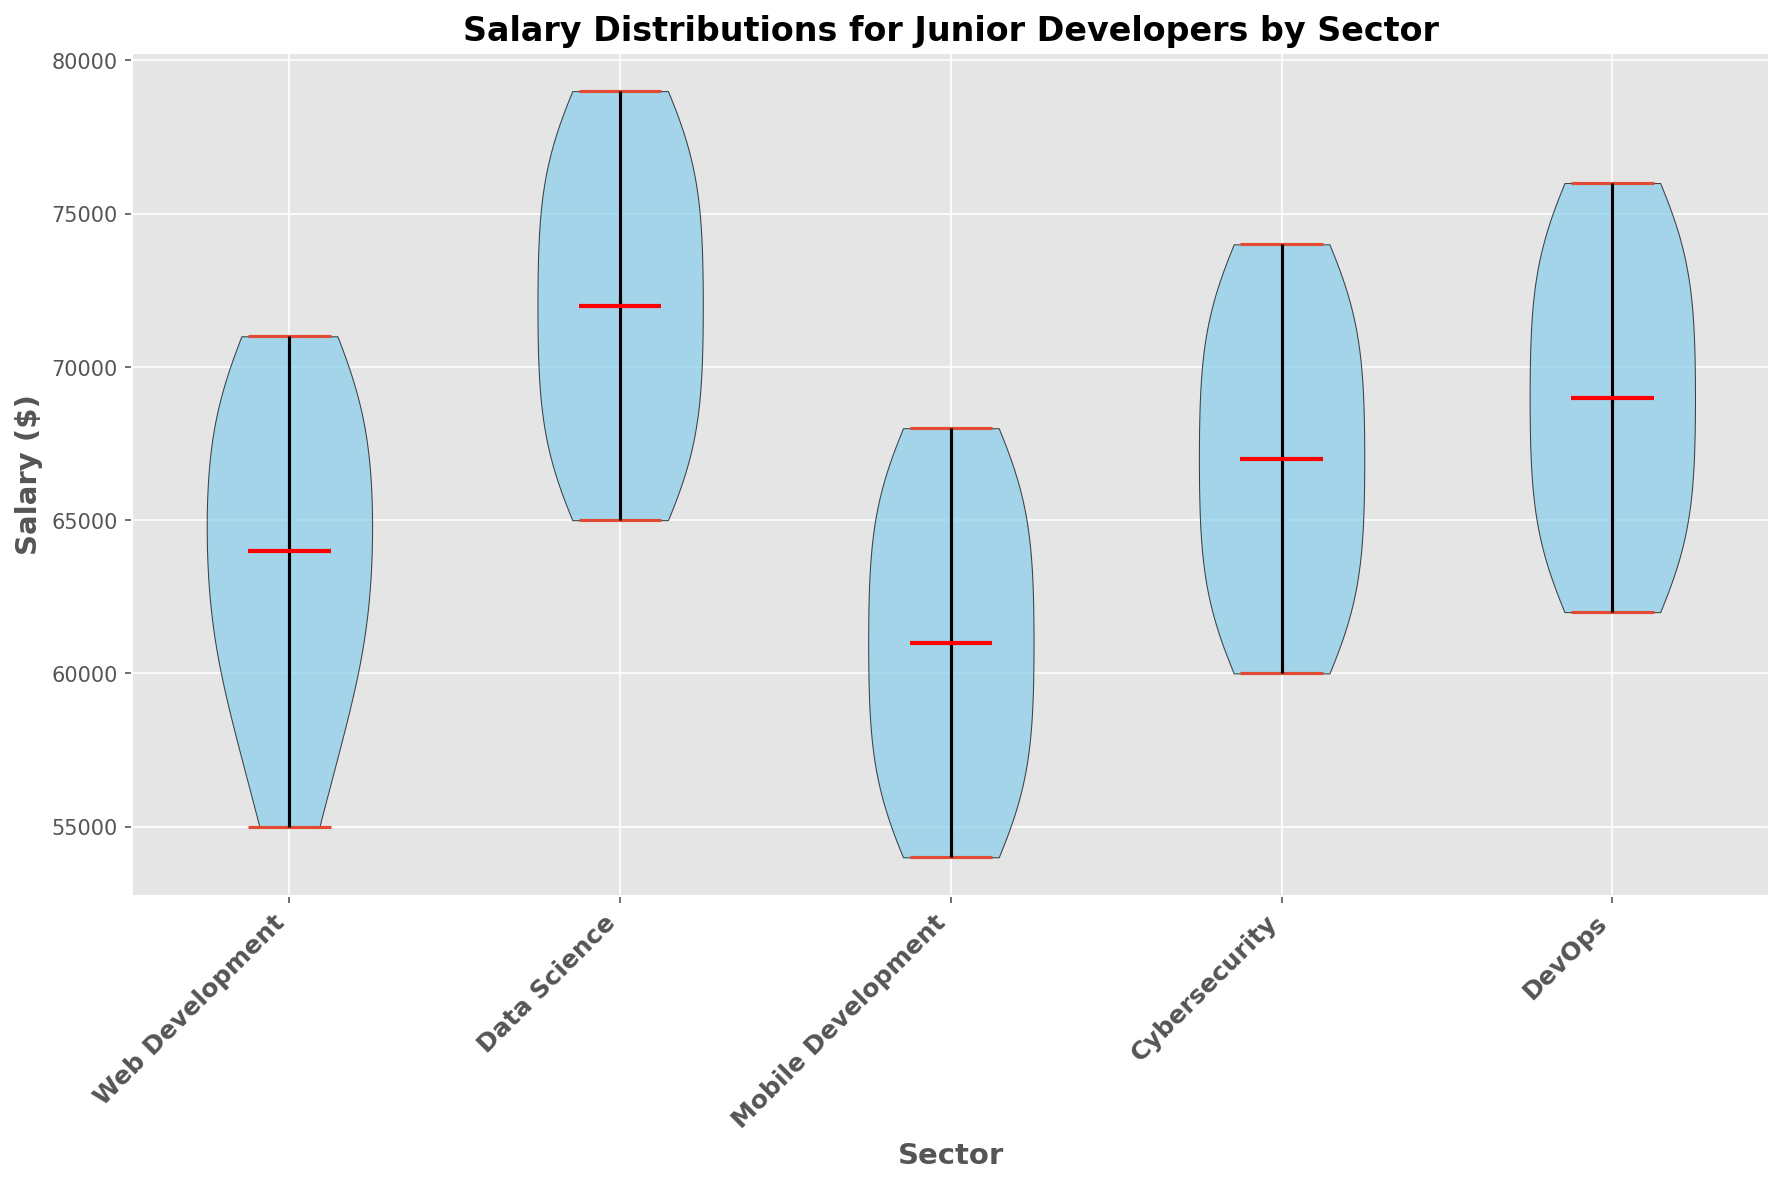How many sectors are represented in the plot? There are five sectors listed on the x-axis of the violin plot, each representing a different area of the tech industry.
Answer: Five Which sector has the widest salary distribution range? The width of the distribution range is visible in the violin plot as the spread from top to bottom. Comparing the spreads for each sector, "DevOps" appears to have the widest range.
Answer: DevOps What is the median salary for Data Science? The median is indicated by the red line within each violin plot. For Data Science, the red line is positioned at $71000.
Answer: $71000 Which sector shows the highest median salary? By observing the red lines across all sectors, Data Science has the highest median salary.
Answer: Data Science Compare the median salaries of Mobile Development and Cybersecurity. Which one is higher and by how much? The median salary (red line) in Mobile Development is $62000, and in Cybersecurity, it's $68000. The difference is $68000 - $62000 = $6000.
Answer: Cybersecurity is higher by $6000 What is the average of the median salaries across all sectors? Add the median salaries: Web Development ($65000), Data Science ($71000), Mobile Development ($62000), Cybersecurity ($68000), and DevOps ($70000). Then, average them: ($65000 + $71000 + $62000 + $68000 + $70000) / 5 = $67200.
Answer: $67200 Which sector's salary distribution appears most symmetric? A symmetric distribution would look evenly spread around the median. Web Development appears to have a relatively symmetric distribution compared to others.
Answer: Web Development Is there any sector where the salary distribution does not cover a $10000 range? Evaluate the range by checking the top and bottom of each violin plot. Mobile Development's distribution ranges from $54000 to $68000, which is exactly $10000, so every sector covers at least $10000.
Answer: No Compare the shape of the salary distributions for Cybersecurity and DevOps. Which one seems more uniform? A uniform distribution would have an even spread. Cybersecurity’s distribution is more uniform compared to DevOps, which shows more variance.
Answer: Cybersecurity 